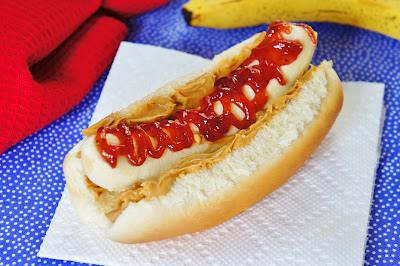Question: where was the photo taken?
Choices:
A. On a sofa.
B. By the bathtub.
C. On the countertop.
D. At a table.
Answer with the letter. Answer: D Question: how many hotdogs are there?
Choices:
A. Four.
B. One.
C. Seventeen.
D. Ten.
Answer with the letter. Answer: B Question: what fruit is in the photo?
Choices:
A. A banana.
B. Apple.
C. Grapes.
D. Oranges.
Answer with the letter. Answer: A 